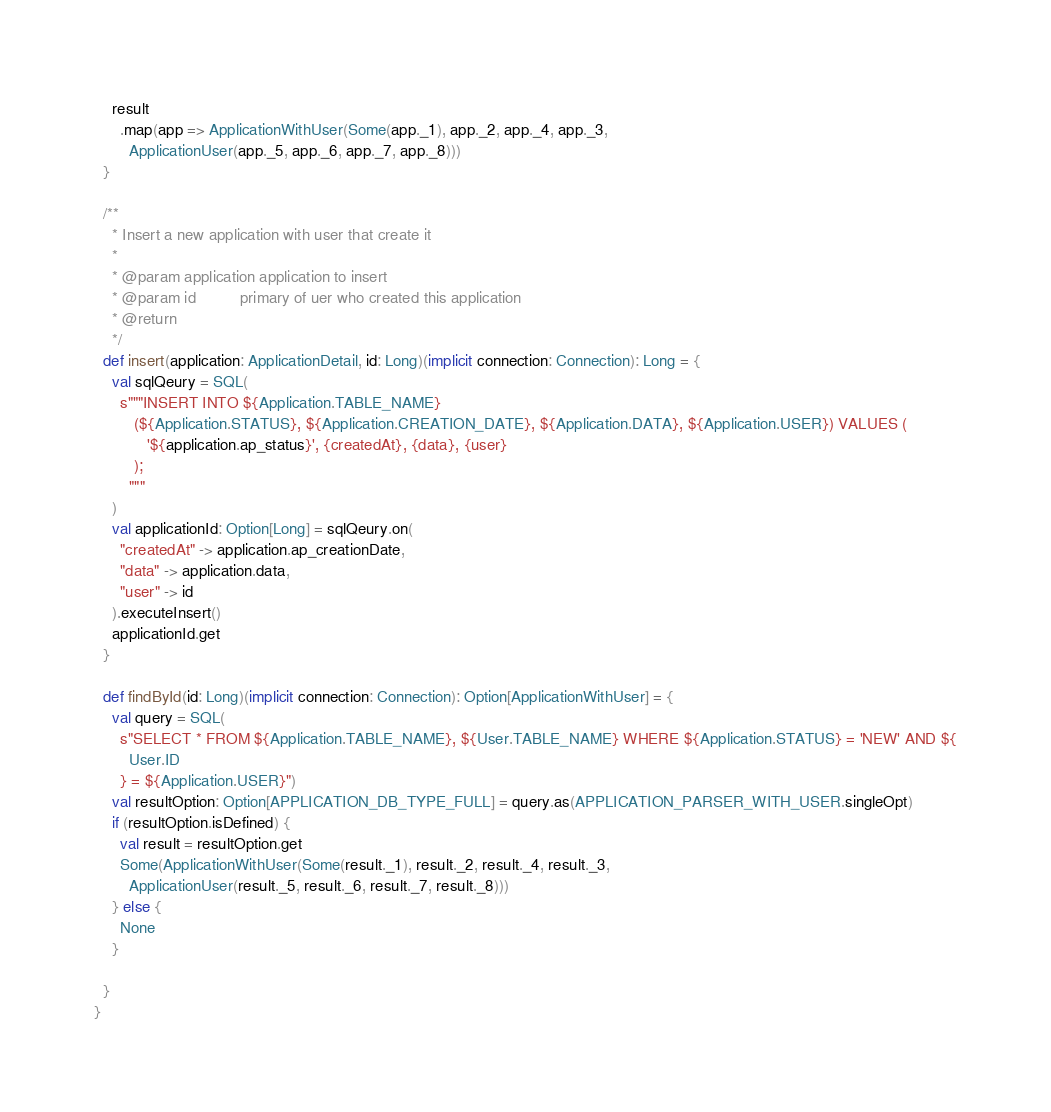<code> <loc_0><loc_0><loc_500><loc_500><_Scala_>    result
      .map(app => ApplicationWithUser(Some(app._1), app._2, app._4, app._3,
        ApplicationUser(app._5, app._6, app._7, app._8)))
  }

  /**
    * Insert a new application with user that create it
    *
    * @param application application to insert
    * @param id          primary of uer who created this application
    * @return
    */
  def insert(application: ApplicationDetail, id: Long)(implicit connection: Connection): Long = {
    val sqlQeury = SQL(
      s"""INSERT INTO ${Application.TABLE_NAME}
         (${Application.STATUS}, ${Application.CREATION_DATE}, ${Application.DATA}, ${Application.USER}) VALUES (
            '${application.ap_status}', {createdAt}, {data}, {user}
         );
        """
    )
    val applicationId: Option[Long] = sqlQeury.on(
      "createdAt" -> application.ap_creationDate,
      "data" -> application.data,
      "user" -> id
    ).executeInsert()
    applicationId.get
  }

  def findById(id: Long)(implicit connection: Connection): Option[ApplicationWithUser] = {
    val query = SQL(
      s"SELECT * FROM ${Application.TABLE_NAME}, ${User.TABLE_NAME} WHERE ${Application.STATUS} = 'NEW' AND ${
        User.ID
      } = ${Application.USER}")
    val resultOption: Option[APPLICATION_DB_TYPE_FULL] = query.as(APPLICATION_PARSER_WITH_USER.singleOpt)
    if (resultOption.isDefined) {
      val result = resultOption.get
      Some(ApplicationWithUser(Some(result._1), result._2, result._4, result._3,
        ApplicationUser(result._5, result._6, result._7, result._8)))
    } else {
      None
    }

  }
}
</code> 